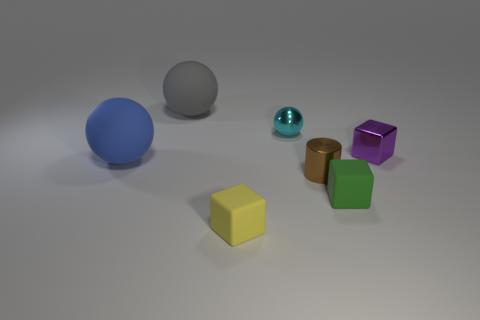Add 2 small red metallic blocks. How many objects exist? 9 Subtract all cylinders. How many objects are left? 6 Subtract all large green rubber blocks. Subtract all gray balls. How many objects are left? 6 Add 4 purple metallic cubes. How many purple metallic cubes are left? 5 Add 3 large gray spheres. How many large gray spheres exist? 4 Subtract 1 cyan balls. How many objects are left? 6 